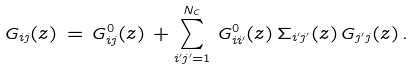Convert formula to latex. <formula><loc_0><loc_0><loc_500><loc_500>G _ { i j } ( z ) \, = \, G ^ { 0 } _ { i j } ( z ) \, + \sum _ { i ^ { \prime } j ^ { \prime } = 1 } ^ { N _ { C } } \, G ^ { 0 } _ { i i ^ { \prime } } ( z ) \, \Sigma _ { i ^ { \prime } j ^ { \prime } } ( z ) \, G _ { j ^ { \prime } j } ( z ) \, .</formula> 